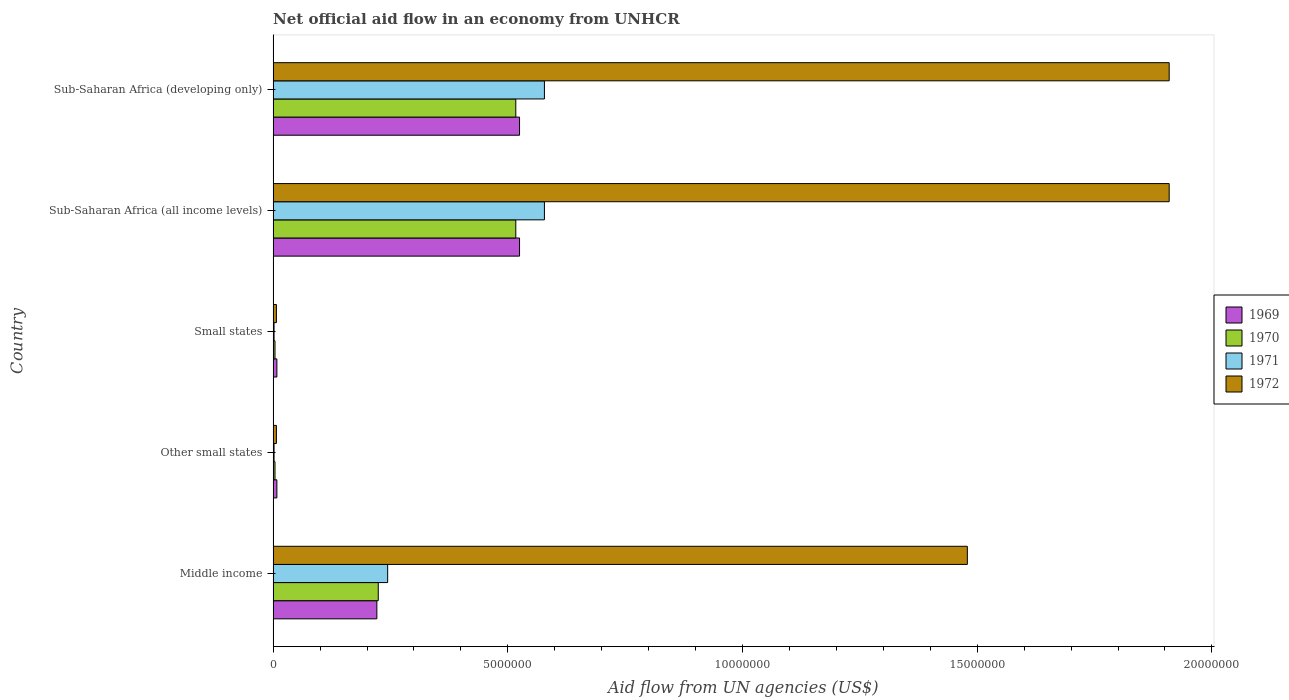How many different coloured bars are there?
Provide a short and direct response. 4. How many groups of bars are there?
Provide a succinct answer. 5. How many bars are there on the 2nd tick from the top?
Your answer should be very brief. 4. How many bars are there on the 1st tick from the bottom?
Ensure brevity in your answer.  4. What is the label of the 4th group of bars from the top?
Keep it short and to the point. Other small states. What is the net official aid flow in 1972 in Sub-Saharan Africa (developing only)?
Offer a very short reply. 1.91e+07. Across all countries, what is the maximum net official aid flow in 1971?
Provide a succinct answer. 5.78e+06. Across all countries, what is the minimum net official aid flow in 1969?
Offer a terse response. 8.00e+04. In which country was the net official aid flow in 1972 maximum?
Provide a short and direct response. Sub-Saharan Africa (all income levels). In which country was the net official aid flow in 1969 minimum?
Offer a very short reply. Other small states. What is the total net official aid flow in 1972 in the graph?
Provide a succinct answer. 5.31e+07. What is the difference between the net official aid flow in 1971 in Small states and that in Sub-Saharan Africa (developing only)?
Your answer should be compact. -5.76e+06. What is the difference between the net official aid flow in 1969 in Sub-Saharan Africa (all income levels) and the net official aid flow in 1972 in Middle income?
Make the answer very short. -9.54e+06. What is the average net official aid flow in 1972 per country?
Offer a very short reply. 1.06e+07. What is the difference between the net official aid flow in 1969 and net official aid flow in 1970 in Sub-Saharan Africa (all income levels)?
Ensure brevity in your answer.  8.00e+04. Is the net official aid flow in 1971 in Middle income less than that in Sub-Saharan Africa (all income levels)?
Make the answer very short. Yes. Is the difference between the net official aid flow in 1969 in Other small states and Sub-Saharan Africa (developing only) greater than the difference between the net official aid flow in 1970 in Other small states and Sub-Saharan Africa (developing only)?
Your answer should be compact. No. What is the difference between the highest and the second highest net official aid flow in 1972?
Offer a terse response. 0. What is the difference between the highest and the lowest net official aid flow in 1969?
Keep it short and to the point. 5.17e+06. In how many countries, is the net official aid flow in 1969 greater than the average net official aid flow in 1969 taken over all countries?
Keep it short and to the point. 2. Is the sum of the net official aid flow in 1972 in Middle income and Small states greater than the maximum net official aid flow in 1970 across all countries?
Your response must be concise. Yes. What does the 1st bar from the bottom in Sub-Saharan Africa (all income levels) represents?
Offer a terse response. 1969. Is it the case that in every country, the sum of the net official aid flow in 1969 and net official aid flow in 1971 is greater than the net official aid flow in 1972?
Provide a succinct answer. No. Does the graph contain grids?
Offer a terse response. No. Where does the legend appear in the graph?
Your response must be concise. Center right. How many legend labels are there?
Your response must be concise. 4. How are the legend labels stacked?
Offer a terse response. Vertical. What is the title of the graph?
Your response must be concise. Net official aid flow in an economy from UNHCR. Does "1996" appear as one of the legend labels in the graph?
Give a very brief answer. No. What is the label or title of the X-axis?
Offer a terse response. Aid flow from UN agencies (US$). What is the Aid flow from UN agencies (US$) in 1969 in Middle income?
Your answer should be compact. 2.21e+06. What is the Aid flow from UN agencies (US$) of 1970 in Middle income?
Make the answer very short. 2.24e+06. What is the Aid flow from UN agencies (US$) in 1971 in Middle income?
Provide a short and direct response. 2.44e+06. What is the Aid flow from UN agencies (US$) of 1972 in Middle income?
Give a very brief answer. 1.48e+07. What is the Aid flow from UN agencies (US$) in 1970 in Other small states?
Provide a short and direct response. 4.00e+04. What is the Aid flow from UN agencies (US$) in 1972 in Other small states?
Your answer should be compact. 7.00e+04. What is the Aid flow from UN agencies (US$) of 1970 in Small states?
Provide a short and direct response. 4.00e+04. What is the Aid flow from UN agencies (US$) of 1972 in Small states?
Your answer should be compact. 7.00e+04. What is the Aid flow from UN agencies (US$) in 1969 in Sub-Saharan Africa (all income levels)?
Ensure brevity in your answer.  5.25e+06. What is the Aid flow from UN agencies (US$) in 1970 in Sub-Saharan Africa (all income levels)?
Make the answer very short. 5.17e+06. What is the Aid flow from UN agencies (US$) in 1971 in Sub-Saharan Africa (all income levels)?
Keep it short and to the point. 5.78e+06. What is the Aid flow from UN agencies (US$) in 1972 in Sub-Saharan Africa (all income levels)?
Provide a short and direct response. 1.91e+07. What is the Aid flow from UN agencies (US$) of 1969 in Sub-Saharan Africa (developing only)?
Provide a short and direct response. 5.25e+06. What is the Aid flow from UN agencies (US$) in 1970 in Sub-Saharan Africa (developing only)?
Offer a very short reply. 5.17e+06. What is the Aid flow from UN agencies (US$) of 1971 in Sub-Saharan Africa (developing only)?
Provide a short and direct response. 5.78e+06. What is the Aid flow from UN agencies (US$) of 1972 in Sub-Saharan Africa (developing only)?
Your answer should be compact. 1.91e+07. Across all countries, what is the maximum Aid flow from UN agencies (US$) in 1969?
Provide a short and direct response. 5.25e+06. Across all countries, what is the maximum Aid flow from UN agencies (US$) in 1970?
Provide a succinct answer. 5.17e+06. Across all countries, what is the maximum Aid flow from UN agencies (US$) in 1971?
Your answer should be compact. 5.78e+06. Across all countries, what is the maximum Aid flow from UN agencies (US$) in 1972?
Provide a succinct answer. 1.91e+07. Across all countries, what is the minimum Aid flow from UN agencies (US$) in 1972?
Keep it short and to the point. 7.00e+04. What is the total Aid flow from UN agencies (US$) of 1969 in the graph?
Your answer should be compact. 1.29e+07. What is the total Aid flow from UN agencies (US$) in 1970 in the graph?
Your answer should be compact. 1.27e+07. What is the total Aid flow from UN agencies (US$) of 1971 in the graph?
Give a very brief answer. 1.40e+07. What is the total Aid flow from UN agencies (US$) in 1972 in the graph?
Make the answer very short. 5.31e+07. What is the difference between the Aid flow from UN agencies (US$) of 1969 in Middle income and that in Other small states?
Provide a short and direct response. 2.13e+06. What is the difference between the Aid flow from UN agencies (US$) in 1970 in Middle income and that in Other small states?
Keep it short and to the point. 2.20e+06. What is the difference between the Aid flow from UN agencies (US$) in 1971 in Middle income and that in Other small states?
Your response must be concise. 2.42e+06. What is the difference between the Aid flow from UN agencies (US$) of 1972 in Middle income and that in Other small states?
Make the answer very short. 1.47e+07. What is the difference between the Aid flow from UN agencies (US$) in 1969 in Middle income and that in Small states?
Ensure brevity in your answer.  2.13e+06. What is the difference between the Aid flow from UN agencies (US$) of 1970 in Middle income and that in Small states?
Your answer should be compact. 2.20e+06. What is the difference between the Aid flow from UN agencies (US$) of 1971 in Middle income and that in Small states?
Offer a very short reply. 2.42e+06. What is the difference between the Aid flow from UN agencies (US$) of 1972 in Middle income and that in Small states?
Make the answer very short. 1.47e+07. What is the difference between the Aid flow from UN agencies (US$) of 1969 in Middle income and that in Sub-Saharan Africa (all income levels)?
Keep it short and to the point. -3.04e+06. What is the difference between the Aid flow from UN agencies (US$) in 1970 in Middle income and that in Sub-Saharan Africa (all income levels)?
Ensure brevity in your answer.  -2.93e+06. What is the difference between the Aid flow from UN agencies (US$) of 1971 in Middle income and that in Sub-Saharan Africa (all income levels)?
Make the answer very short. -3.34e+06. What is the difference between the Aid flow from UN agencies (US$) of 1972 in Middle income and that in Sub-Saharan Africa (all income levels)?
Provide a short and direct response. -4.30e+06. What is the difference between the Aid flow from UN agencies (US$) in 1969 in Middle income and that in Sub-Saharan Africa (developing only)?
Ensure brevity in your answer.  -3.04e+06. What is the difference between the Aid flow from UN agencies (US$) in 1970 in Middle income and that in Sub-Saharan Africa (developing only)?
Give a very brief answer. -2.93e+06. What is the difference between the Aid flow from UN agencies (US$) of 1971 in Middle income and that in Sub-Saharan Africa (developing only)?
Offer a very short reply. -3.34e+06. What is the difference between the Aid flow from UN agencies (US$) in 1972 in Middle income and that in Sub-Saharan Africa (developing only)?
Give a very brief answer. -4.30e+06. What is the difference between the Aid flow from UN agencies (US$) of 1969 in Other small states and that in Small states?
Provide a short and direct response. 0. What is the difference between the Aid flow from UN agencies (US$) in 1970 in Other small states and that in Small states?
Provide a short and direct response. 0. What is the difference between the Aid flow from UN agencies (US$) in 1971 in Other small states and that in Small states?
Ensure brevity in your answer.  0. What is the difference between the Aid flow from UN agencies (US$) in 1969 in Other small states and that in Sub-Saharan Africa (all income levels)?
Give a very brief answer. -5.17e+06. What is the difference between the Aid flow from UN agencies (US$) in 1970 in Other small states and that in Sub-Saharan Africa (all income levels)?
Offer a very short reply. -5.13e+06. What is the difference between the Aid flow from UN agencies (US$) in 1971 in Other small states and that in Sub-Saharan Africa (all income levels)?
Your answer should be very brief. -5.76e+06. What is the difference between the Aid flow from UN agencies (US$) in 1972 in Other small states and that in Sub-Saharan Africa (all income levels)?
Offer a very short reply. -1.90e+07. What is the difference between the Aid flow from UN agencies (US$) of 1969 in Other small states and that in Sub-Saharan Africa (developing only)?
Give a very brief answer. -5.17e+06. What is the difference between the Aid flow from UN agencies (US$) of 1970 in Other small states and that in Sub-Saharan Africa (developing only)?
Offer a terse response. -5.13e+06. What is the difference between the Aid flow from UN agencies (US$) of 1971 in Other small states and that in Sub-Saharan Africa (developing only)?
Give a very brief answer. -5.76e+06. What is the difference between the Aid flow from UN agencies (US$) of 1972 in Other small states and that in Sub-Saharan Africa (developing only)?
Offer a very short reply. -1.90e+07. What is the difference between the Aid flow from UN agencies (US$) of 1969 in Small states and that in Sub-Saharan Africa (all income levels)?
Your answer should be compact. -5.17e+06. What is the difference between the Aid flow from UN agencies (US$) of 1970 in Small states and that in Sub-Saharan Africa (all income levels)?
Provide a succinct answer. -5.13e+06. What is the difference between the Aid flow from UN agencies (US$) in 1971 in Small states and that in Sub-Saharan Africa (all income levels)?
Your answer should be compact. -5.76e+06. What is the difference between the Aid flow from UN agencies (US$) in 1972 in Small states and that in Sub-Saharan Africa (all income levels)?
Provide a short and direct response. -1.90e+07. What is the difference between the Aid flow from UN agencies (US$) in 1969 in Small states and that in Sub-Saharan Africa (developing only)?
Keep it short and to the point. -5.17e+06. What is the difference between the Aid flow from UN agencies (US$) of 1970 in Small states and that in Sub-Saharan Africa (developing only)?
Your response must be concise. -5.13e+06. What is the difference between the Aid flow from UN agencies (US$) of 1971 in Small states and that in Sub-Saharan Africa (developing only)?
Offer a terse response. -5.76e+06. What is the difference between the Aid flow from UN agencies (US$) in 1972 in Small states and that in Sub-Saharan Africa (developing only)?
Make the answer very short. -1.90e+07. What is the difference between the Aid flow from UN agencies (US$) in 1971 in Sub-Saharan Africa (all income levels) and that in Sub-Saharan Africa (developing only)?
Make the answer very short. 0. What is the difference between the Aid flow from UN agencies (US$) of 1969 in Middle income and the Aid flow from UN agencies (US$) of 1970 in Other small states?
Keep it short and to the point. 2.17e+06. What is the difference between the Aid flow from UN agencies (US$) of 1969 in Middle income and the Aid flow from UN agencies (US$) of 1971 in Other small states?
Offer a terse response. 2.19e+06. What is the difference between the Aid flow from UN agencies (US$) of 1969 in Middle income and the Aid flow from UN agencies (US$) of 1972 in Other small states?
Keep it short and to the point. 2.14e+06. What is the difference between the Aid flow from UN agencies (US$) of 1970 in Middle income and the Aid flow from UN agencies (US$) of 1971 in Other small states?
Give a very brief answer. 2.22e+06. What is the difference between the Aid flow from UN agencies (US$) in 1970 in Middle income and the Aid flow from UN agencies (US$) in 1972 in Other small states?
Make the answer very short. 2.17e+06. What is the difference between the Aid flow from UN agencies (US$) of 1971 in Middle income and the Aid flow from UN agencies (US$) of 1972 in Other small states?
Ensure brevity in your answer.  2.37e+06. What is the difference between the Aid flow from UN agencies (US$) in 1969 in Middle income and the Aid flow from UN agencies (US$) in 1970 in Small states?
Make the answer very short. 2.17e+06. What is the difference between the Aid flow from UN agencies (US$) of 1969 in Middle income and the Aid flow from UN agencies (US$) of 1971 in Small states?
Give a very brief answer. 2.19e+06. What is the difference between the Aid flow from UN agencies (US$) of 1969 in Middle income and the Aid flow from UN agencies (US$) of 1972 in Small states?
Make the answer very short. 2.14e+06. What is the difference between the Aid flow from UN agencies (US$) of 1970 in Middle income and the Aid flow from UN agencies (US$) of 1971 in Small states?
Ensure brevity in your answer.  2.22e+06. What is the difference between the Aid flow from UN agencies (US$) of 1970 in Middle income and the Aid flow from UN agencies (US$) of 1972 in Small states?
Provide a succinct answer. 2.17e+06. What is the difference between the Aid flow from UN agencies (US$) of 1971 in Middle income and the Aid flow from UN agencies (US$) of 1972 in Small states?
Ensure brevity in your answer.  2.37e+06. What is the difference between the Aid flow from UN agencies (US$) of 1969 in Middle income and the Aid flow from UN agencies (US$) of 1970 in Sub-Saharan Africa (all income levels)?
Provide a short and direct response. -2.96e+06. What is the difference between the Aid flow from UN agencies (US$) in 1969 in Middle income and the Aid flow from UN agencies (US$) in 1971 in Sub-Saharan Africa (all income levels)?
Your answer should be compact. -3.57e+06. What is the difference between the Aid flow from UN agencies (US$) of 1969 in Middle income and the Aid flow from UN agencies (US$) of 1972 in Sub-Saharan Africa (all income levels)?
Offer a very short reply. -1.69e+07. What is the difference between the Aid flow from UN agencies (US$) of 1970 in Middle income and the Aid flow from UN agencies (US$) of 1971 in Sub-Saharan Africa (all income levels)?
Keep it short and to the point. -3.54e+06. What is the difference between the Aid flow from UN agencies (US$) in 1970 in Middle income and the Aid flow from UN agencies (US$) in 1972 in Sub-Saharan Africa (all income levels)?
Your answer should be very brief. -1.68e+07. What is the difference between the Aid flow from UN agencies (US$) of 1971 in Middle income and the Aid flow from UN agencies (US$) of 1972 in Sub-Saharan Africa (all income levels)?
Offer a terse response. -1.66e+07. What is the difference between the Aid flow from UN agencies (US$) of 1969 in Middle income and the Aid flow from UN agencies (US$) of 1970 in Sub-Saharan Africa (developing only)?
Make the answer very short. -2.96e+06. What is the difference between the Aid flow from UN agencies (US$) of 1969 in Middle income and the Aid flow from UN agencies (US$) of 1971 in Sub-Saharan Africa (developing only)?
Offer a very short reply. -3.57e+06. What is the difference between the Aid flow from UN agencies (US$) of 1969 in Middle income and the Aid flow from UN agencies (US$) of 1972 in Sub-Saharan Africa (developing only)?
Keep it short and to the point. -1.69e+07. What is the difference between the Aid flow from UN agencies (US$) in 1970 in Middle income and the Aid flow from UN agencies (US$) in 1971 in Sub-Saharan Africa (developing only)?
Ensure brevity in your answer.  -3.54e+06. What is the difference between the Aid flow from UN agencies (US$) in 1970 in Middle income and the Aid flow from UN agencies (US$) in 1972 in Sub-Saharan Africa (developing only)?
Make the answer very short. -1.68e+07. What is the difference between the Aid flow from UN agencies (US$) of 1971 in Middle income and the Aid flow from UN agencies (US$) of 1972 in Sub-Saharan Africa (developing only)?
Keep it short and to the point. -1.66e+07. What is the difference between the Aid flow from UN agencies (US$) in 1969 in Other small states and the Aid flow from UN agencies (US$) in 1972 in Small states?
Offer a very short reply. 10000. What is the difference between the Aid flow from UN agencies (US$) in 1969 in Other small states and the Aid flow from UN agencies (US$) in 1970 in Sub-Saharan Africa (all income levels)?
Make the answer very short. -5.09e+06. What is the difference between the Aid flow from UN agencies (US$) of 1969 in Other small states and the Aid flow from UN agencies (US$) of 1971 in Sub-Saharan Africa (all income levels)?
Give a very brief answer. -5.70e+06. What is the difference between the Aid flow from UN agencies (US$) of 1969 in Other small states and the Aid flow from UN agencies (US$) of 1972 in Sub-Saharan Africa (all income levels)?
Your answer should be very brief. -1.90e+07. What is the difference between the Aid flow from UN agencies (US$) of 1970 in Other small states and the Aid flow from UN agencies (US$) of 1971 in Sub-Saharan Africa (all income levels)?
Keep it short and to the point. -5.74e+06. What is the difference between the Aid flow from UN agencies (US$) in 1970 in Other small states and the Aid flow from UN agencies (US$) in 1972 in Sub-Saharan Africa (all income levels)?
Give a very brief answer. -1.90e+07. What is the difference between the Aid flow from UN agencies (US$) of 1971 in Other small states and the Aid flow from UN agencies (US$) of 1972 in Sub-Saharan Africa (all income levels)?
Your answer should be compact. -1.91e+07. What is the difference between the Aid flow from UN agencies (US$) in 1969 in Other small states and the Aid flow from UN agencies (US$) in 1970 in Sub-Saharan Africa (developing only)?
Keep it short and to the point. -5.09e+06. What is the difference between the Aid flow from UN agencies (US$) in 1969 in Other small states and the Aid flow from UN agencies (US$) in 1971 in Sub-Saharan Africa (developing only)?
Give a very brief answer. -5.70e+06. What is the difference between the Aid flow from UN agencies (US$) in 1969 in Other small states and the Aid flow from UN agencies (US$) in 1972 in Sub-Saharan Africa (developing only)?
Give a very brief answer. -1.90e+07. What is the difference between the Aid flow from UN agencies (US$) in 1970 in Other small states and the Aid flow from UN agencies (US$) in 1971 in Sub-Saharan Africa (developing only)?
Provide a short and direct response. -5.74e+06. What is the difference between the Aid flow from UN agencies (US$) of 1970 in Other small states and the Aid flow from UN agencies (US$) of 1972 in Sub-Saharan Africa (developing only)?
Keep it short and to the point. -1.90e+07. What is the difference between the Aid flow from UN agencies (US$) in 1971 in Other small states and the Aid flow from UN agencies (US$) in 1972 in Sub-Saharan Africa (developing only)?
Your response must be concise. -1.91e+07. What is the difference between the Aid flow from UN agencies (US$) of 1969 in Small states and the Aid flow from UN agencies (US$) of 1970 in Sub-Saharan Africa (all income levels)?
Give a very brief answer. -5.09e+06. What is the difference between the Aid flow from UN agencies (US$) of 1969 in Small states and the Aid flow from UN agencies (US$) of 1971 in Sub-Saharan Africa (all income levels)?
Your answer should be very brief. -5.70e+06. What is the difference between the Aid flow from UN agencies (US$) in 1969 in Small states and the Aid flow from UN agencies (US$) in 1972 in Sub-Saharan Africa (all income levels)?
Give a very brief answer. -1.90e+07. What is the difference between the Aid flow from UN agencies (US$) in 1970 in Small states and the Aid flow from UN agencies (US$) in 1971 in Sub-Saharan Africa (all income levels)?
Your answer should be very brief. -5.74e+06. What is the difference between the Aid flow from UN agencies (US$) in 1970 in Small states and the Aid flow from UN agencies (US$) in 1972 in Sub-Saharan Africa (all income levels)?
Make the answer very short. -1.90e+07. What is the difference between the Aid flow from UN agencies (US$) of 1971 in Small states and the Aid flow from UN agencies (US$) of 1972 in Sub-Saharan Africa (all income levels)?
Provide a short and direct response. -1.91e+07. What is the difference between the Aid flow from UN agencies (US$) in 1969 in Small states and the Aid flow from UN agencies (US$) in 1970 in Sub-Saharan Africa (developing only)?
Offer a terse response. -5.09e+06. What is the difference between the Aid flow from UN agencies (US$) of 1969 in Small states and the Aid flow from UN agencies (US$) of 1971 in Sub-Saharan Africa (developing only)?
Offer a very short reply. -5.70e+06. What is the difference between the Aid flow from UN agencies (US$) in 1969 in Small states and the Aid flow from UN agencies (US$) in 1972 in Sub-Saharan Africa (developing only)?
Provide a succinct answer. -1.90e+07. What is the difference between the Aid flow from UN agencies (US$) of 1970 in Small states and the Aid flow from UN agencies (US$) of 1971 in Sub-Saharan Africa (developing only)?
Offer a very short reply. -5.74e+06. What is the difference between the Aid flow from UN agencies (US$) in 1970 in Small states and the Aid flow from UN agencies (US$) in 1972 in Sub-Saharan Africa (developing only)?
Provide a succinct answer. -1.90e+07. What is the difference between the Aid flow from UN agencies (US$) of 1971 in Small states and the Aid flow from UN agencies (US$) of 1972 in Sub-Saharan Africa (developing only)?
Keep it short and to the point. -1.91e+07. What is the difference between the Aid flow from UN agencies (US$) of 1969 in Sub-Saharan Africa (all income levels) and the Aid flow from UN agencies (US$) of 1971 in Sub-Saharan Africa (developing only)?
Your answer should be compact. -5.30e+05. What is the difference between the Aid flow from UN agencies (US$) of 1969 in Sub-Saharan Africa (all income levels) and the Aid flow from UN agencies (US$) of 1972 in Sub-Saharan Africa (developing only)?
Keep it short and to the point. -1.38e+07. What is the difference between the Aid flow from UN agencies (US$) in 1970 in Sub-Saharan Africa (all income levels) and the Aid flow from UN agencies (US$) in 1971 in Sub-Saharan Africa (developing only)?
Ensure brevity in your answer.  -6.10e+05. What is the difference between the Aid flow from UN agencies (US$) in 1970 in Sub-Saharan Africa (all income levels) and the Aid flow from UN agencies (US$) in 1972 in Sub-Saharan Africa (developing only)?
Offer a terse response. -1.39e+07. What is the difference between the Aid flow from UN agencies (US$) of 1971 in Sub-Saharan Africa (all income levels) and the Aid flow from UN agencies (US$) of 1972 in Sub-Saharan Africa (developing only)?
Provide a succinct answer. -1.33e+07. What is the average Aid flow from UN agencies (US$) of 1969 per country?
Make the answer very short. 2.57e+06. What is the average Aid flow from UN agencies (US$) of 1970 per country?
Your answer should be compact. 2.53e+06. What is the average Aid flow from UN agencies (US$) of 1971 per country?
Your answer should be very brief. 2.81e+06. What is the average Aid flow from UN agencies (US$) in 1972 per country?
Your answer should be compact. 1.06e+07. What is the difference between the Aid flow from UN agencies (US$) in 1969 and Aid flow from UN agencies (US$) in 1972 in Middle income?
Offer a terse response. -1.26e+07. What is the difference between the Aid flow from UN agencies (US$) of 1970 and Aid flow from UN agencies (US$) of 1971 in Middle income?
Ensure brevity in your answer.  -2.00e+05. What is the difference between the Aid flow from UN agencies (US$) of 1970 and Aid flow from UN agencies (US$) of 1972 in Middle income?
Ensure brevity in your answer.  -1.26e+07. What is the difference between the Aid flow from UN agencies (US$) in 1971 and Aid flow from UN agencies (US$) in 1972 in Middle income?
Make the answer very short. -1.24e+07. What is the difference between the Aid flow from UN agencies (US$) of 1969 and Aid flow from UN agencies (US$) of 1970 in Other small states?
Your answer should be compact. 4.00e+04. What is the difference between the Aid flow from UN agencies (US$) in 1970 and Aid flow from UN agencies (US$) in 1971 in Other small states?
Offer a terse response. 2.00e+04. What is the difference between the Aid flow from UN agencies (US$) in 1969 and Aid flow from UN agencies (US$) in 1971 in Small states?
Your response must be concise. 6.00e+04. What is the difference between the Aid flow from UN agencies (US$) in 1969 and Aid flow from UN agencies (US$) in 1972 in Small states?
Provide a short and direct response. 10000. What is the difference between the Aid flow from UN agencies (US$) of 1970 and Aid flow from UN agencies (US$) of 1972 in Small states?
Provide a succinct answer. -3.00e+04. What is the difference between the Aid flow from UN agencies (US$) in 1969 and Aid flow from UN agencies (US$) in 1971 in Sub-Saharan Africa (all income levels)?
Your answer should be compact. -5.30e+05. What is the difference between the Aid flow from UN agencies (US$) of 1969 and Aid flow from UN agencies (US$) of 1972 in Sub-Saharan Africa (all income levels)?
Offer a very short reply. -1.38e+07. What is the difference between the Aid flow from UN agencies (US$) in 1970 and Aid flow from UN agencies (US$) in 1971 in Sub-Saharan Africa (all income levels)?
Your answer should be very brief. -6.10e+05. What is the difference between the Aid flow from UN agencies (US$) in 1970 and Aid flow from UN agencies (US$) in 1972 in Sub-Saharan Africa (all income levels)?
Offer a terse response. -1.39e+07. What is the difference between the Aid flow from UN agencies (US$) in 1971 and Aid flow from UN agencies (US$) in 1972 in Sub-Saharan Africa (all income levels)?
Keep it short and to the point. -1.33e+07. What is the difference between the Aid flow from UN agencies (US$) in 1969 and Aid flow from UN agencies (US$) in 1971 in Sub-Saharan Africa (developing only)?
Give a very brief answer. -5.30e+05. What is the difference between the Aid flow from UN agencies (US$) of 1969 and Aid flow from UN agencies (US$) of 1972 in Sub-Saharan Africa (developing only)?
Offer a very short reply. -1.38e+07. What is the difference between the Aid flow from UN agencies (US$) of 1970 and Aid flow from UN agencies (US$) of 1971 in Sub-Saharan Africa (developing only)?
Your answer should be very brief. -6.10e+05. What is the difference between the Aid flow from UN agencies (US$) in 1970 and Aid flow from UN agencies (US$) in 1972 in Sub-Saharan Africa (developing only)?
Offer a terse response. -1.39e+07. What is the difference between the Aid flow from UN agencies (US$) in 1971 and Aid flow from UN agencies (US$) in 1972 in Sub-Saharan Africa (developing only)?
Provide a short and direct response. -1.33e+07. What is the ratio of the Aid flow from UN agencies (US$) of 1969 in Middle income to that in Other small states?
Provide a succinct answer. 27.62. What is the ratio of the Aid flow from UN agencies (US$) of 1970 in Middle income to that in Other small states?
Give a very brief answer. 56. What is the ratio of the Aid flow from UN agencies (US$) in 1971 in Middle income to that in Other small states?
Offer a very short reply. 122. What is the ratio of the Aid flow from UN agencies (US$) in 1972 in Middle income to that in Other small states?
Offer a terse response. 211.29. What is the ratio of the Aid flow from UN agencies (US$) of 1969 in Middle income to that in Small states?
Ensure brevity in your answer.  27.62. What is the ratio of the Aid flow from UN agencies (US$) in 1970 in Middle income to that in Small states?
Your answer should be very brief. 56. What is the ratio of the Aid flow from UN agencies (US$) in 1971 in Middle income to that in Small states?
Offer a terse response. 122. What is the ratio of the Aid flow from UN agencies (US$) in 1972 in Middle income to that in Small states?
Offer a very short reply. 211.29. What is the ratio of the Aid flow from UN agencies (US$) in 1969 in Middle income to that in Sub-Saharan Africa (all income levels)?
Give a very brief answer. 0.42. What is the ratio of the Aid flow from UN agencies (US$) of 1970 in Middle income to that in Sub-Saharan Africa (all income levels)?
Your answer should be compact. 0.43. What is the ratio of the Aid flow from UN agencies (US$) in 1971 in Middle income to that in Sub-Saharan Africa (all income levels)?
Offer a terse response. 0.42. What is the ratio of the Aid flow from UN agencies (US$) in 1972 in Middle income to that in Sub-Saharan Africa (all income levels)?
Keep it short and to the point. 0.77. What is the ratio of the Aid flow from UN agencies (US$) of 1969 in Middle income to that in Sub-Saharan Africa (developing only)?
Ensure brevity in your answer.  0.42. What is the ratio of the Aid flow from UN agencies (US$) in 1970 in Middle income to that in Sub-Saharan Africa (developing only)?
Your answer should be compact. 0.43. What is the ratio of the Aid flow from UN agencies (US$) of 1971 in Middle income to that in Sub-Saharan Africa (developing only)?
Make the answer very short. 0.42. What is the ratio of the Aid flow from UN agencies (US$) in 1972 in Middle income to that in Sub-Saharan Africa (developing only)?
Your answer should be very brief. 0.77. What is the ratio of the Aid flow from UN agencies (US$) in 1969 in Other small states to that in Small states?
Provide a succinct answer. 1. What is the ratio of the Aid flow from UN agencies (US$) of 1971 in Other small states to that in Small states?
Offer a very short reply. 1. What is the ratio of the Aid flow from UN agencies (US$) of 1969 in Other small states to that in Sub-Saharan Africa (all income levels)?
Your response must be concise. 0.02. What is the ratio of the Aid flow from UN agencies (US$) of 1970 in Other small states to that in Sub-Saharan Africa (all income levels)?
Offer a very short reply. 0.01. What is the ratio of the Aid flow from UN agencies (US$) in 1971 in Other small states to that in Sub-Saharan Africa (all income levels)?
Provide a succinct answer. 0. What is the ratio of the Aid flow from UN agencies (US$) in 1972 in Other small states to that in Sub-Saharan Africa (all income levels)?
Your response must be concise. 0. What is the ratio of the Aid flow from UN agencies (US$) in 1969 in Other small states to that in Sub-Saharan Africa (developing only)?
Offer a very short reply. 0.02. What is the ratio of the Aid flow from UN agencies (US$) in 1970 in Other small states to that in Sub-Saharan Africa (developing only)?
Offer a terse response. 0.01. What is the ratio of the Aid flow from UN agencies (US$) in 1971 in Other small states to that in Sub-Saharan Africa (developing only)?
Your answer should be compact. 0. What is the ratio of the Aid flow from UN agencies (US$) of 1972 in Other small states to that in Sub-Saharan Africa (developing only)?
Your answer should be very brief. 0. What is the ratio of the Aid flow from UN agencies (US$) in 1969 in Small states to that in Sub-Saharan Africa (all income levels)?
Offer a terse response. 0.02. What is the ratio of the Aid flow from UN agencies (US$) in 1970 in Small states to that in Sub-Saharan Africa (all income levels)?
Your response must be concise. 0.01. What is the ratio of the Aid flow from UN agencies (US$) in 1971 in Small states to that in Sub-Saharan Africa (all income levels)?
Your answer should be very brief. 0. What is the ratio of the Aid flow from UN agencies (US$) of 1972 in Small states to that in Sub-Saharan Africa (all income levels)?
Offer a very short reply. 0. What is the ratio of the Aid flow from UN agencies (US$) in 1969 in Small states to that in Sub-Saharan Africa (developing only)?
Ensure brevity in your answer.  0.02. What is the ratio of the Aid flow from UN agencies (US$) of 1970 in Small states to that in Sub-Saharan Africa (developing only)?
Your answer should be compact. 0.01. What is the ratio of the Aid flow from UN agencies (US$) in 1971 in Small states to that in Sub-Saharan Africa (developing only)?
Keep it short and to the point. 0. What is the ratio of the Aid flow from UN agencies (US$) in 1972 in Small states to that in Sub-Saharan Africa (developing only)?
Offer a terse response. 0. What is the ratio of the Aid flow from UN agencies (US$) of 1969 in Sub-Saharan Africa (all income levels) to that in Sub-Saharan Africa (developing only)?
Make the answer very short. 1. What is the ratio of the Aid flow from UN agencies (US$) in 1970 in Sub-Saharan Africa (all income levels) to that in Sub-Saharan Africa (developing only)?
Your answer should be very brief. 1. What is the ratio of the Aid flow from UN agencies (US$) in 1972 in Sub-Saharan Africa (all income levels) to that in Sub-Saharan Africa (developing only)?
Keep it short and to the point. 1. What is the difference between the highest and the second highest Aid flow from UN agencies (US$) of 1970?
Provide a short and direct response. 0. What is the difference between the highest and the second highest Aid flow from UN agencies (US$) of 1971?
Your response must be concise. 0. What is the difference between the highest and the lowest Aid flow from UN agencies (US$) of 1969?
Ensure brevity in your answer.  5.17e+06. What is the difference between the highest and the lowest Aid flow from UN agencies (US$) of 1970?
Make the answer very short. 5.13e+06. What is the difference between the highest and the lowest Aid flow from UN agencies (US$) of 1971?
Your response must be concise. 5.76e+06. What is the difference between the highest and the lowest Aid flow from UN agencies (US$) of 1972?
Provide a short and direct response. 1.90e+07. 